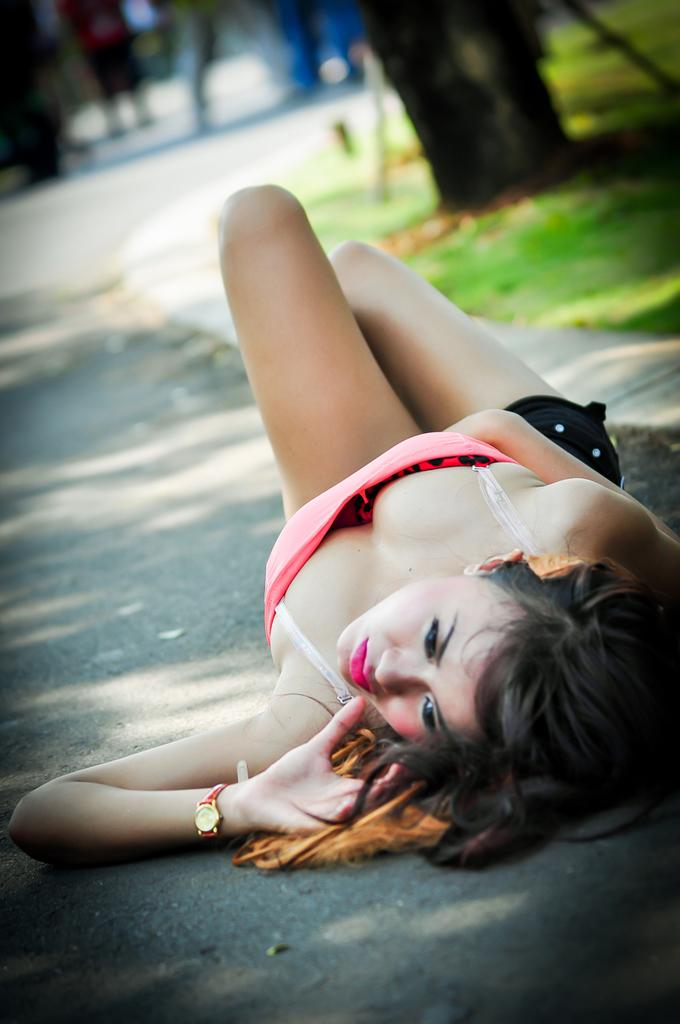What is the main subject of the image? There is a lady lying on the road in the image. Can you describe the surroundings of the lady? There are other people visible in the background of the image, and there is a tree trunk in the background as well. What type of oil can be seen dripping from the lady's hair in the image? There is no oil visible in the image, and the lady's hair is not shown dripping with any substance. 